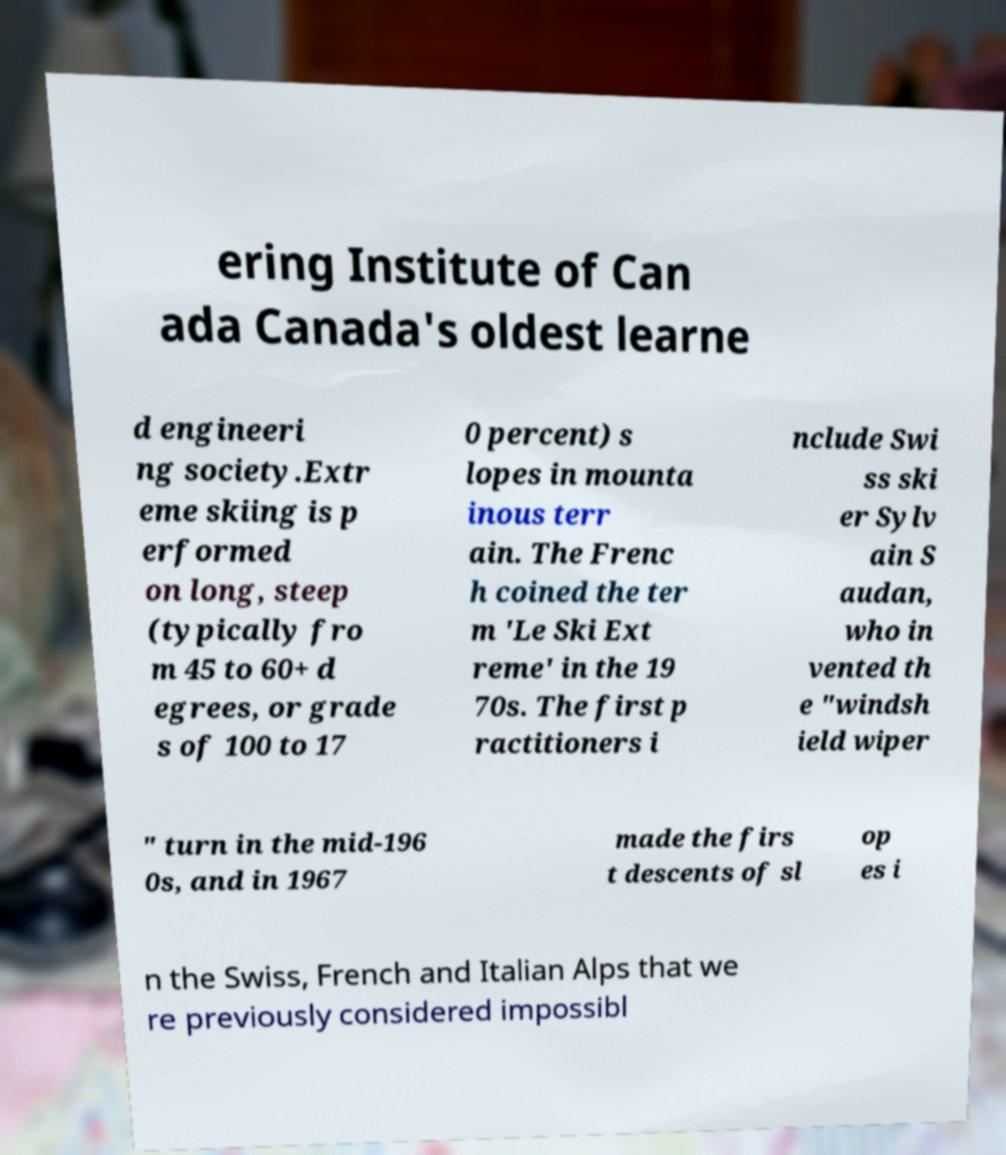Please identify and transcribe the text found in this image. ering Institute of Can ada Canada's oldest learne d engineeri ng society.Extr eme skiing is p erformed on long, steep (typically fro m 45 to 60+ d egrees, or grade s of 100 to 17 0 percent) s lopes in mounta inous terr ain. The Frenc h coined the ter m 'Le Ski Ext reme' in the 19 70s. The first p ractitioners i nclude Swi ss ski er Sylv ain S audan, who in vented th e "windsh ield wiper " turn in the mid-196 0s, and in 1967 made the firs t descents of sl op es i n the Swiss, French and Italian Alps that we re previously considered impossibl 